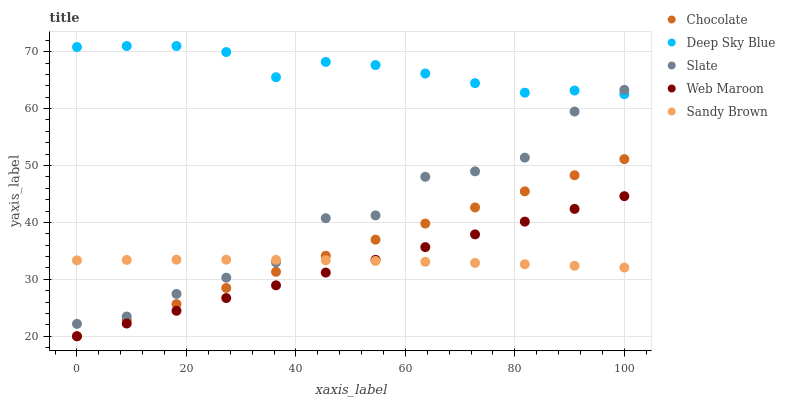Does Web Maroon have the minimum area under the curve?
Answer yes or no. Yes. Does Deep Sky Blue have the maximum area under the curve?
Answer yes or no. Yes. Does Slate have the minimum area under the curve?
Answer yes or no. No. Does Slate have the maximum area under the curve?
Answer yes or no. No. Is Web Maroon the smoothest?
Answer yes or no. Yes. Is Slate the roughest?
Answer yes or no. Yes. Is Slate the smoothest?
Answer yes or no. No. Is Web Maroon the roughest?
Answer yes or no. No. Does Web Maroon have the lowest value?
Answer yes or no. Yes. Does Slate have the lowest value?
Answer yes or no. No. Does Deep Sky Blue have the highest value?
Answer yes or no. Yes. Does Slate have the highest value?
Answer yes or no. No. Is Chocolate less than Slate?
Answer yes or no. Yes. Is Deep Sky Blue greater than Web Maroon?
Answer yes or no. Yes. Does Web Maroon intersect Sandy Brown?
Answer yes or no. Yes. Is Web Maroon less than Sandy Brown?
Answer yes or no. No. Is Web Maroon greater than Sandy Brown?
Answer yes or no. No. Does Chocolate intersect Slate?
Answer yes or no. No. 